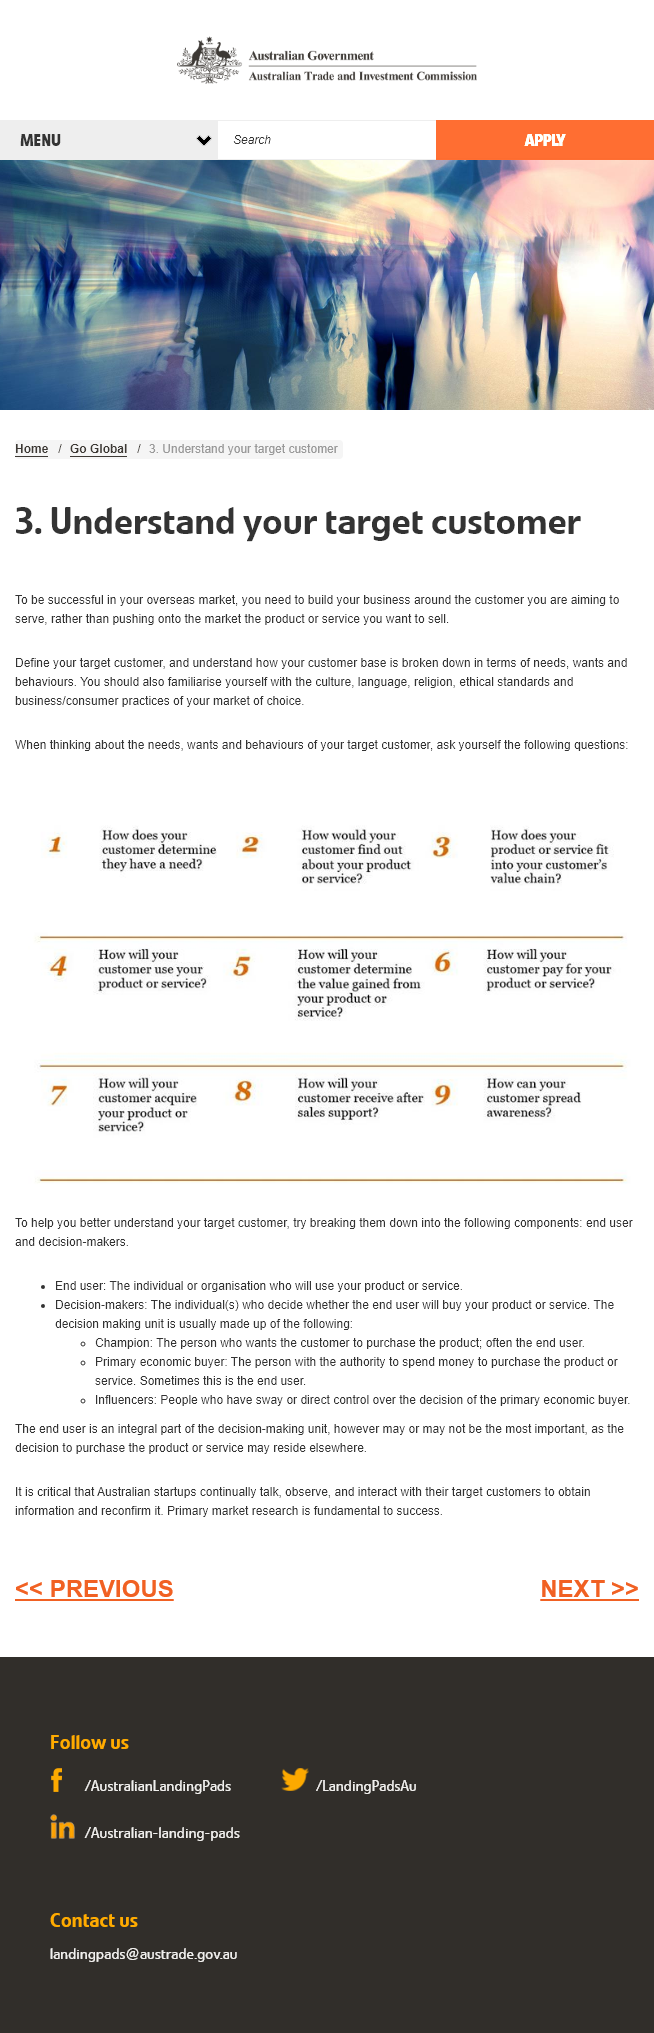Highlight a few significant elements in this photo. To achieve success in your overseas market, it is crucial to build your business around the target customer you aim to serve. In order to effectively understand our customer base, it is essential to categorize them according to their needs, wants, and behaviors. It is crucial to familiarize oneself with the culture, language, ethical standards and business/consumer practices of the target market in order to successfully conduct business and effectively communicate with consumers. 